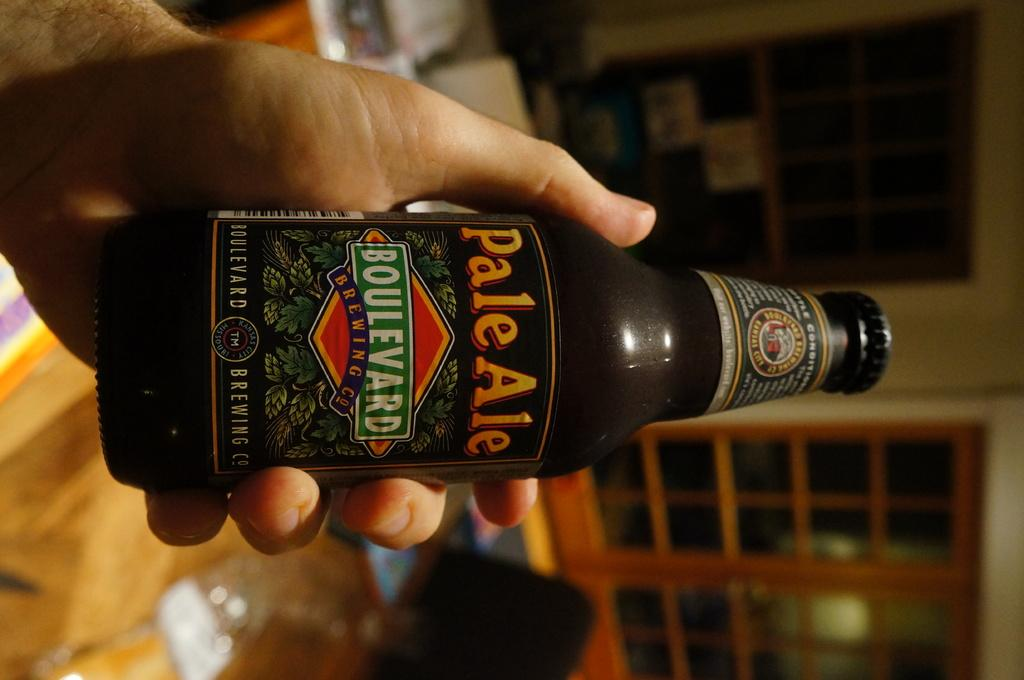<image>
Present a compact description of the photo's key features. A hand holding a bottle of pale ale made by Boulevard Brewing Company. 